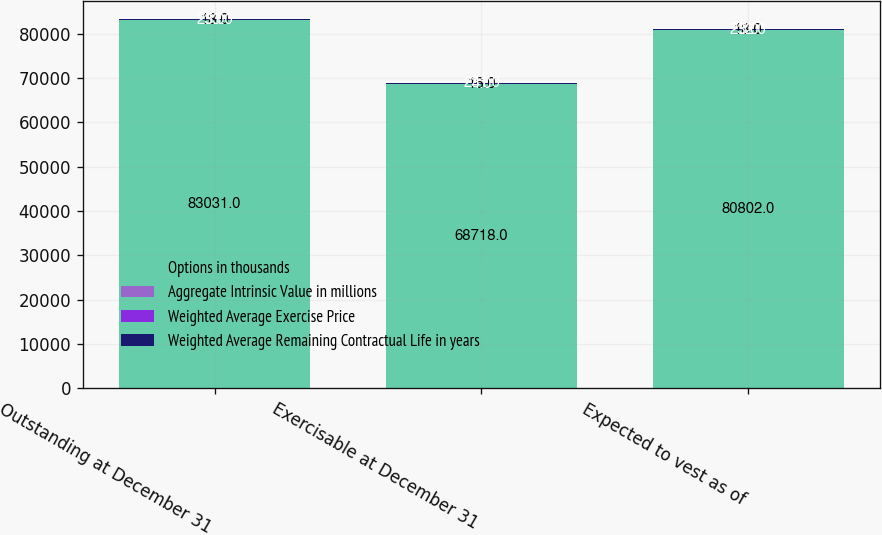Convert chart to OTSL. <chart><loc_0><loc_0><loc_500><loc_500><stacked_bar_chart><ecel><fcel>Outstanding at December 31<fcel>Exercisable at December 31<fcel>Expected to vest as of<nl><fcel>Options in thousands<fcel>83031<fcel>68718<fcel>80802<nl><fcel>Aggregate Intrinsic Value in millions<fcel>18<fcel>16<fcel>18<nl><fcel>Weighted Average Exercise Price<fcel>5<fcel>4<fcel>5<nl><fcel>Weighted Average Remaining Contractual Life in years<fcel>233<fcel>231<fcel>232<nl></chart> 